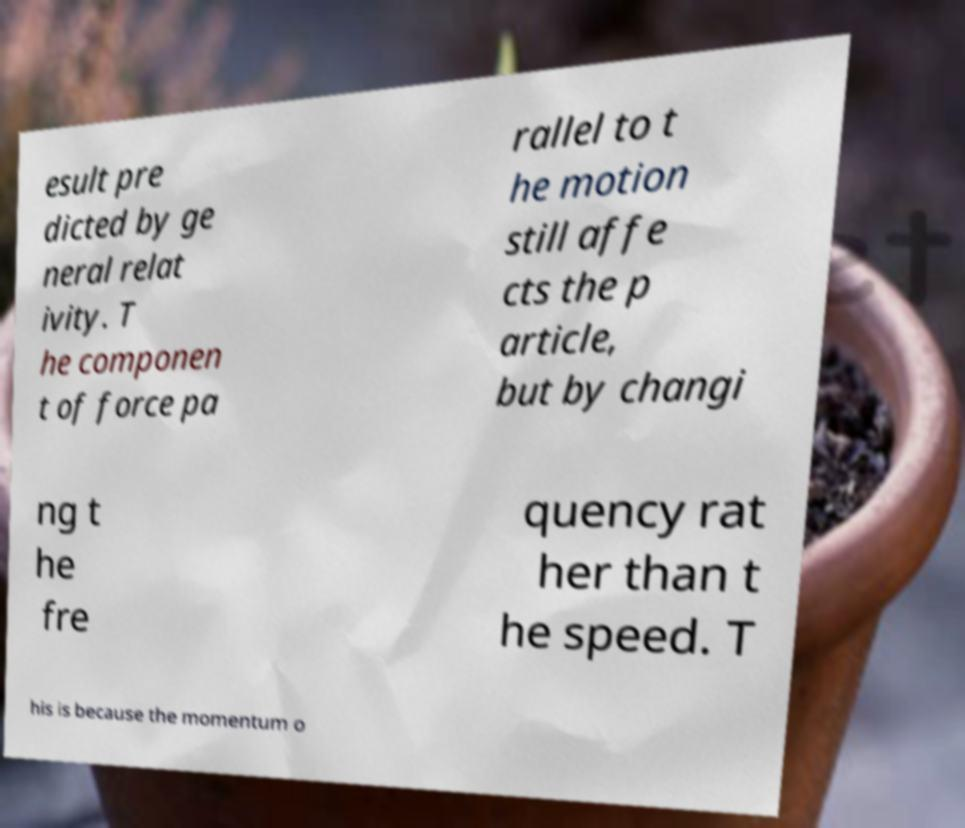Could you assist in decoding the text presented in this image and type it out clearly? esult pre dicted by ge neral relat ivity. T he componen t of force pa rallel to t he motion still affe cts the p article, but by changi ng t he fre quency rat her than t he speed. T his is because the momentum o 